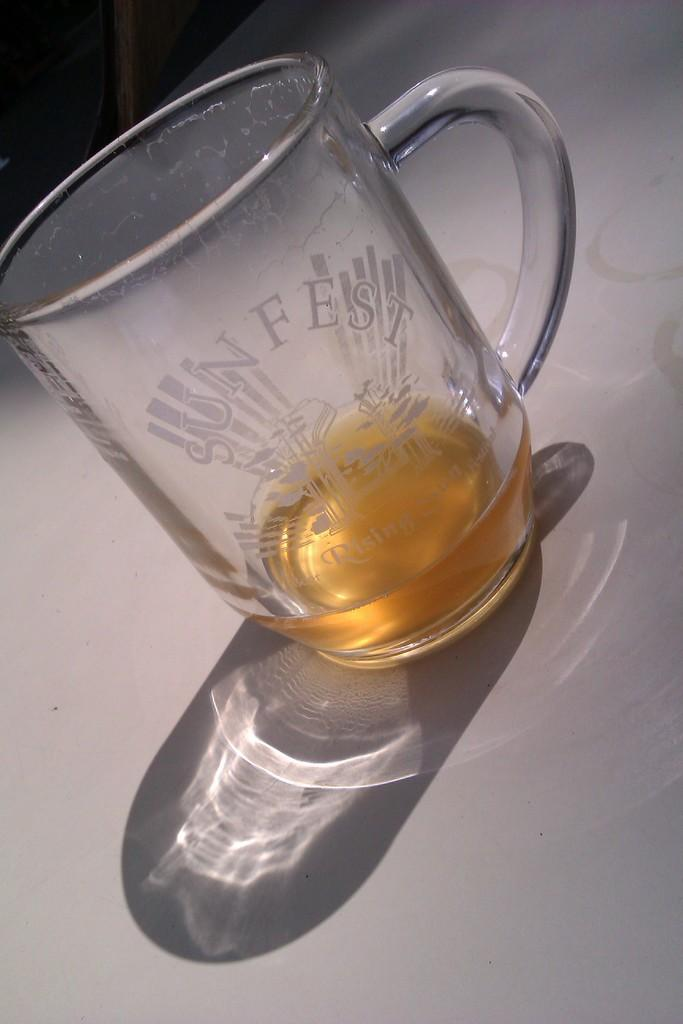What is in the glass that is visible in the image? There is a glass of drink in the image. What additional detail can be observed on the glass? There is writing on the glass. What type of glove is being used to mix the drink in the image? There is no glove present in the image, and the drink does not appear to be mixed. 